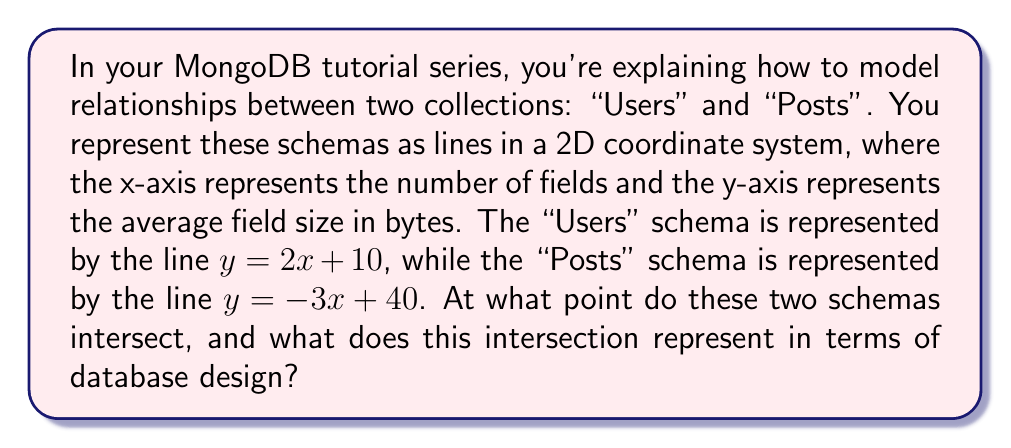Could you help me with this problem? Let's solve this step-by-step:

1) We have two lines:
   Line 1 (Users): $y = 2x + 10$
   Line 2 (Posts): $y = -3x + 40$

2) To find the intersection point, we set these equations equal to each other:
   $2x + 10 = -3x + 40$

3) Now, let's solve for x:
   $2x + 3x = 40 - 10$
   $5x = 30$
   $x = 6$

4) Now that we know x, we can substitute it back into either of the original equations to find y. Let's use the first equation:
   $y = 2(6) + 10$
   $y = 12 + 10 = 22$

5) Therefore, the point of intersection is (6, 22).

6) In terms of database design, this intersection point represents:
   - x = 6: Both schemas have 6 fields at this point
   - y = 22: The average field size for both schemas is 22 bytes at this point

This intersection suggests a balance point where both schemas have the same number of fields and average field size, which could be useful for optimizing queries that join these collections.
Answer: (6, 22) 